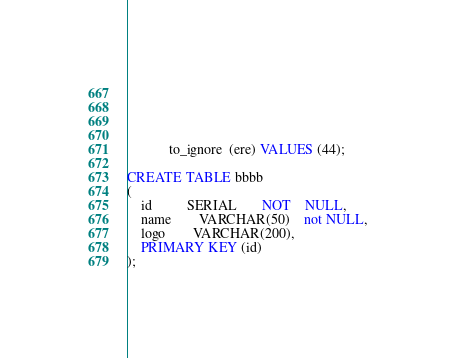Convert code to text. <code><loc_0><loc_0><loc_500><loc_500><_SQL_>            
            
            
            
            to_ignore  (ere) VALUES (44);

CREATE TABLE bbbb
(
    id          SERIAL       NOT    NULL,
    name        VARCHAR(50)    not NULL,
    logo        VARCHAR(200),
    PRIMARY KEY (id)
);</code> 